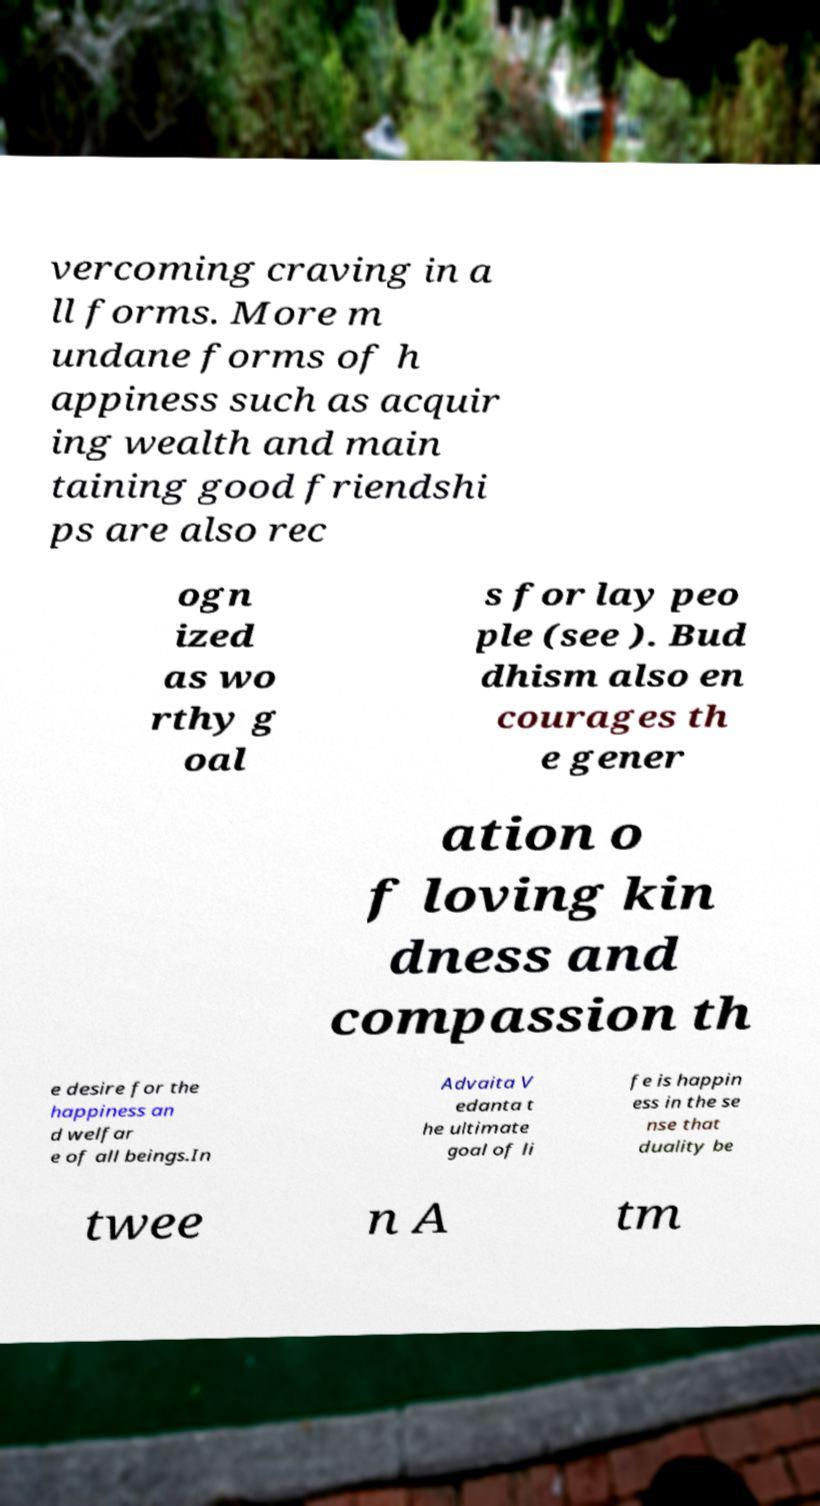Please identify and transcribe the text found in this image. vercoming craving in a ll forms. More m undane forms of h appiness such as acquir ing wealth and main taining good friendshi ps are also rec ogn ized as wo rthy g oal s for lay peo ple (see ). Bud dhism also en courages th e gener ation o f loving kin dness and compassion th e desire for the happiness an d welfar e of all beings.In Advaita V edanta t he ultimate goal of li fe is happin ess in the se nse that duality be twee n A tm 